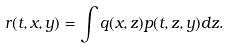<formula> <loc_0><loc_0><loc_500><loc_500>r ( t , x , y ) = \int q ( x , z ) p ( t , z , y ) d z .</formula> 